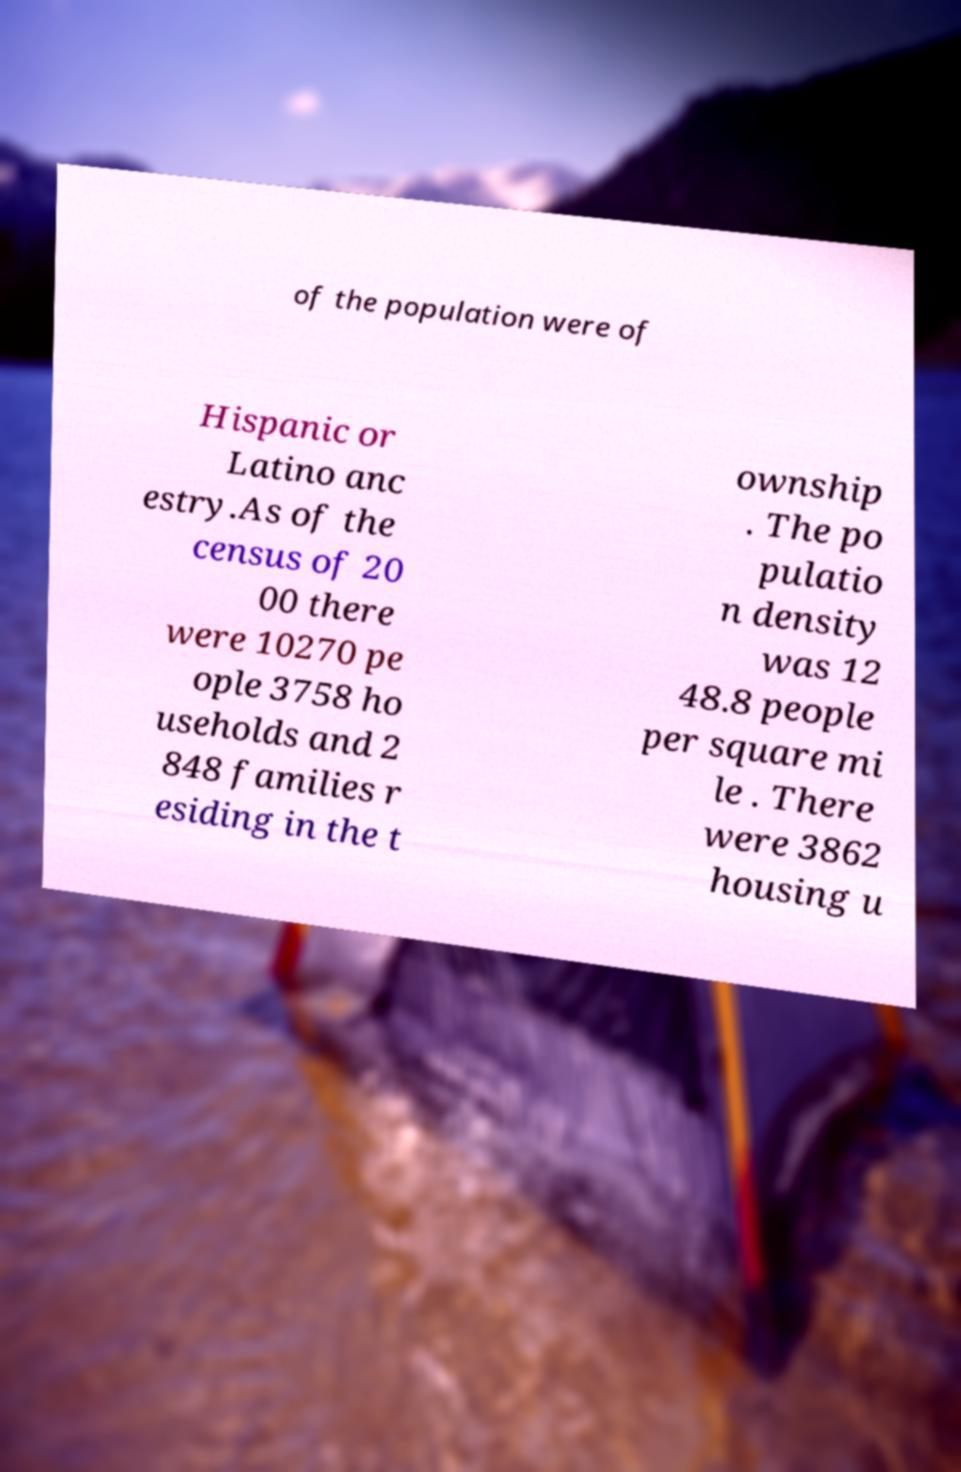Please read and relay the text visible in this image. What does it say? of the population were of Hispanic or Latino anc estry.As of the census of 20 00 there were 10270 pe ople 3758 ho useholds and 2 848 families r esiding in the t ownship . The po pulatio n density was 12 48.8 people per square mi le . There were 3862 housing u 